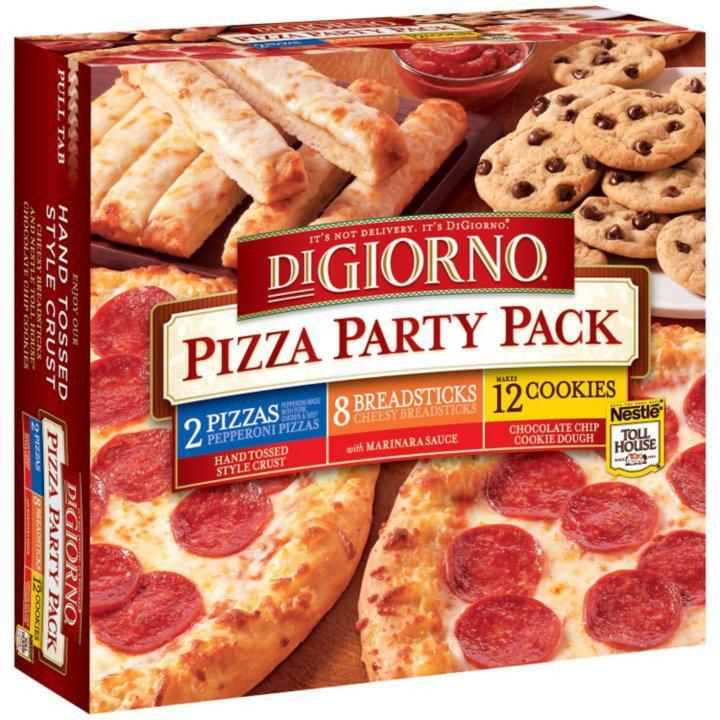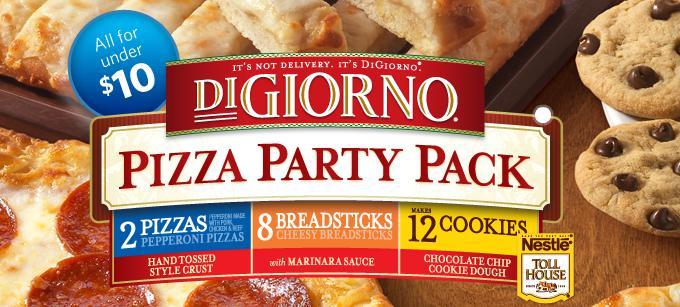The first image is the image on the left, the second image is the image on the right. Examine the images to the left and right. Is the description "Both pizza packs contain Wyngz." accurate? Answer yes or no. No. The first image is the image on the left, the second image is the image on the right. Assess this claim about the two images: "An image shows a pizza box that depicts pizza on the left and coated chicken pieces on the right.". Correct or not? Answer yes or no. No. 